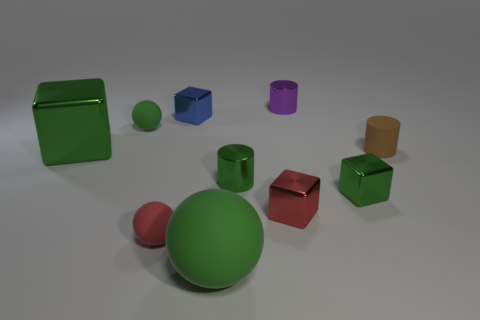Subtract 1 blocks. How many blocks are left? 3 Subtract all blocks. How many objects are left? 6 Subtract 1 blue blocks. How many objects are left? 9 Subtract all yellow matte objects. Subtract all tiny shiny cubes. How many objects are left? 7 Add 4 small red rubber things. How many small red rubber things are left? 5 Add 1 green matte blocks. How many green matte blocks exist? 1 